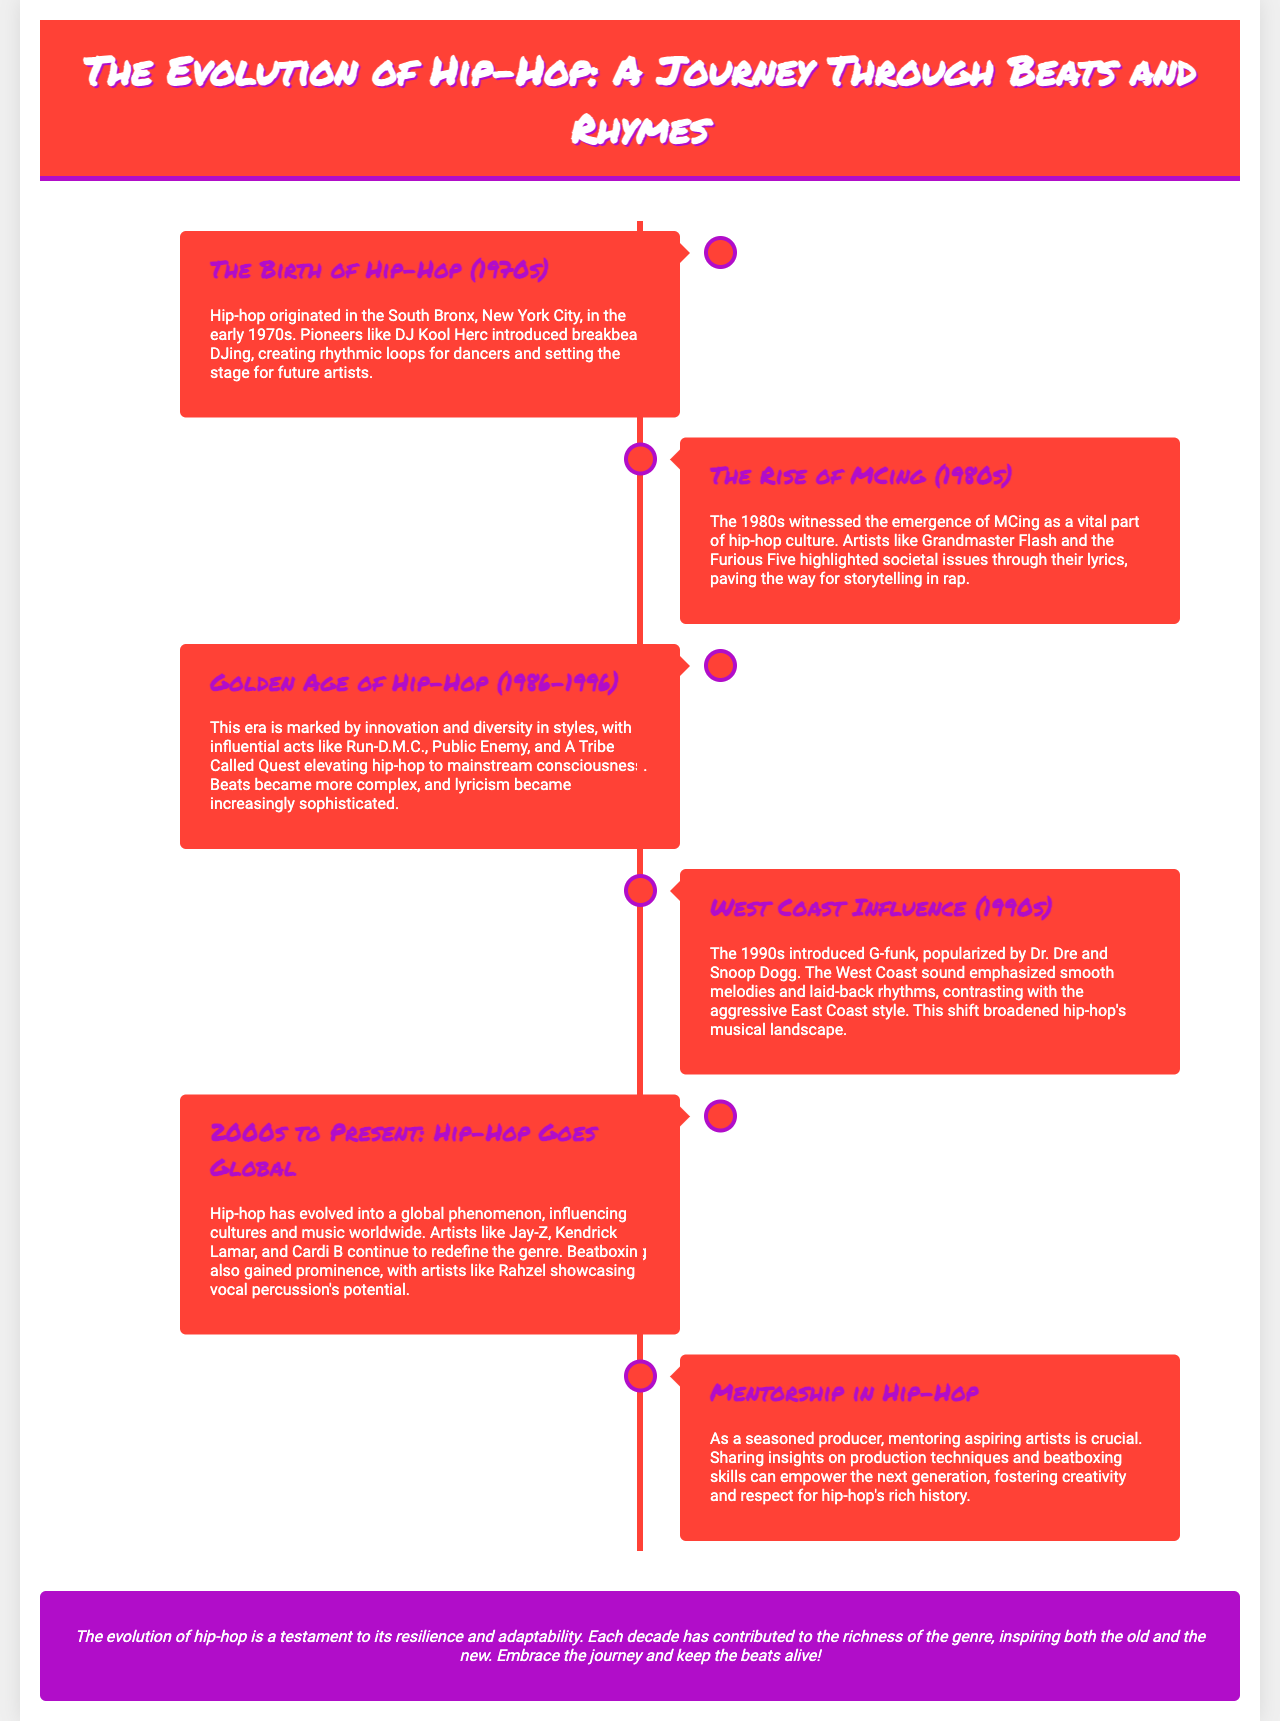What year did hip-hop originate? The document states that hip-hop originated in the early 1970s.
Answer: 1970s Who introduced breakbeat DJing? The timeline mentions DJ Kool Herc as the pioneer who introduced breakbeat DJing.
Answer: DJ Kool Herc What significant event occurred in the 1980s? The document highlights the emergence of MCing as a vital part of hip-hop culture during the 1980s.
Answer: Emergence of MCing Which three acts are noted from the Golden Age of Hip-Hop? The timeline lists Run-D.M.C., Public Enemy, and A Tribe Called Quest as influential acts from this era.
Answer: Run-D.M.C., Public Enemy, A Tribe Called Quest What sound did Dr. Dre popularize? The timeline refers to G-funk as the sound popularized by Dr. Dre.
Answer: G-funk Which artists are mentioned in the 2000s to Present section? The document mentions Jay-Z, Kendrick Lamar, and Cardi B as artists redefining the genre.
Answer: Jay-Z, Kendrick Lamar, Cardi B What role does mentorship play in hip-hop according to the document? The document mentions that mentoring aspiring artists is crucial for sharing insights and fostering creativity.
Answer: Sharing insights What statement summarizes the conclusion about the evolution of hip-hop? The conclusion summarizes that the evolution of hip-hop is a testament to its resilience and adaptability.
Answer: Resilience and adaptability 